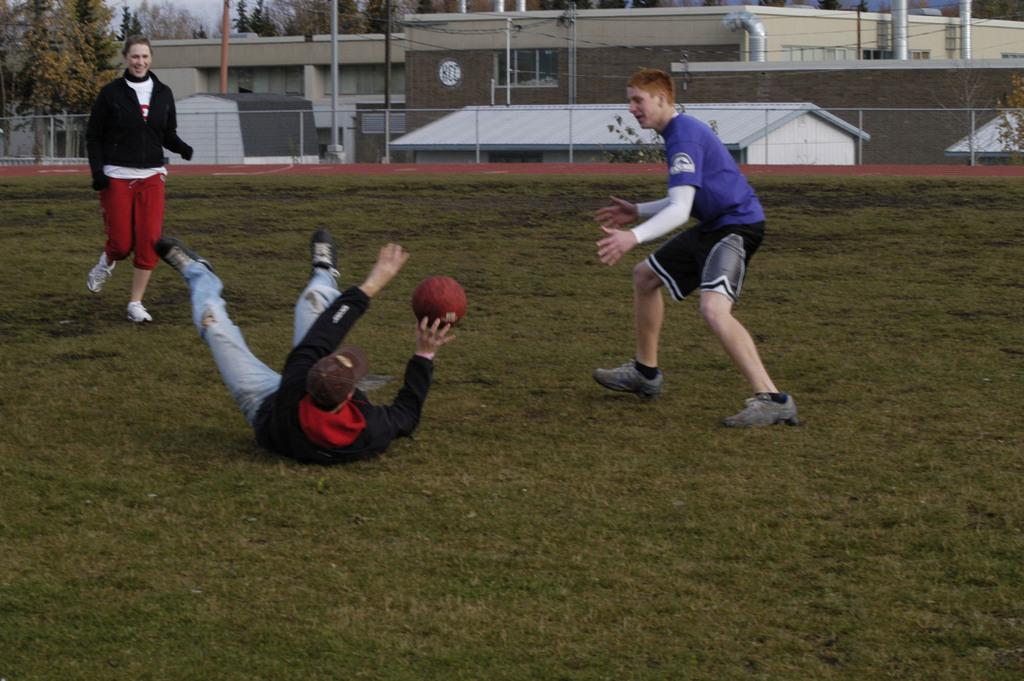What are the people in the image doing? The people in the image are playing with a ball. Where is the game taking place? The game is taking place on a ground. What can be seen in the background of the image? There are buildings and a tree visible in the image. What type of adjustment is being made to the ball during the game? There is no mention of any adjustments being made to the ball in the image. 